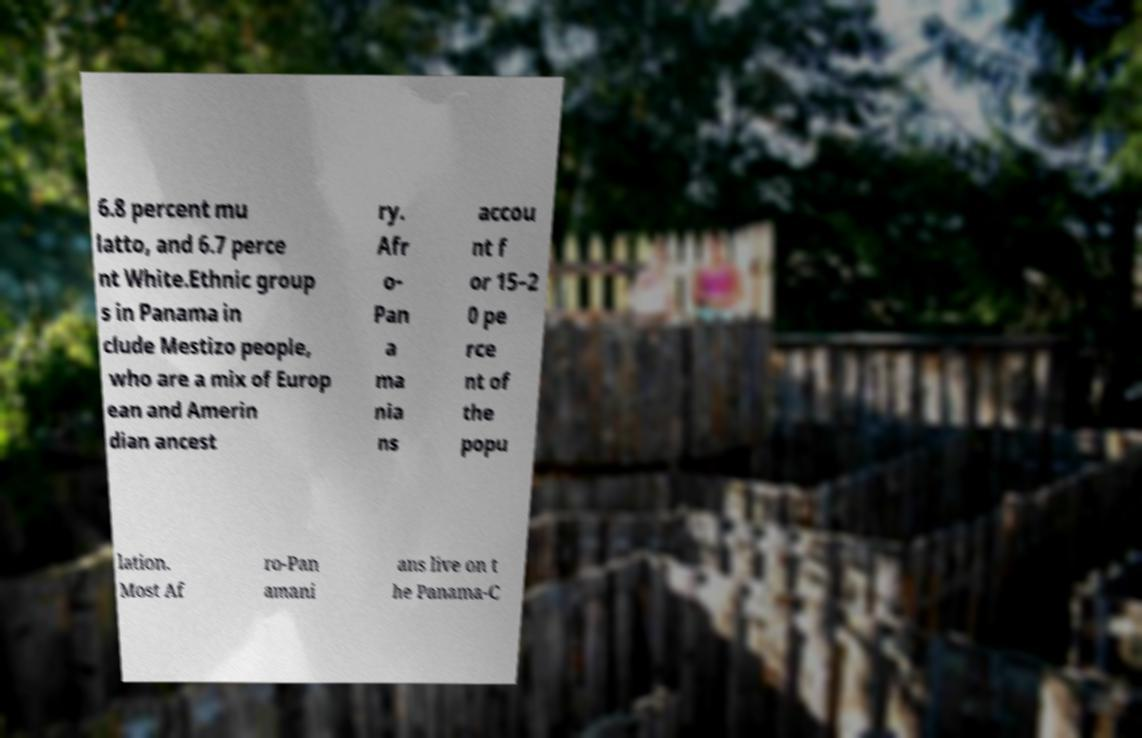There's text embedded in this image that I need extracted. Can you transcribe it verbatim? 6.8 percent mu latto, and 6.7 perce nt White.Ethnic group s in Panama in clude Mestizo people, who are a mix of Europ ean and Amerin dian ancest ry. Afr o- Pan a ma nia ns accou nt f or 15–2 0 pe rce nt of the popu lation. Most Af ro-Pan amani ans live on t he Panama-C 